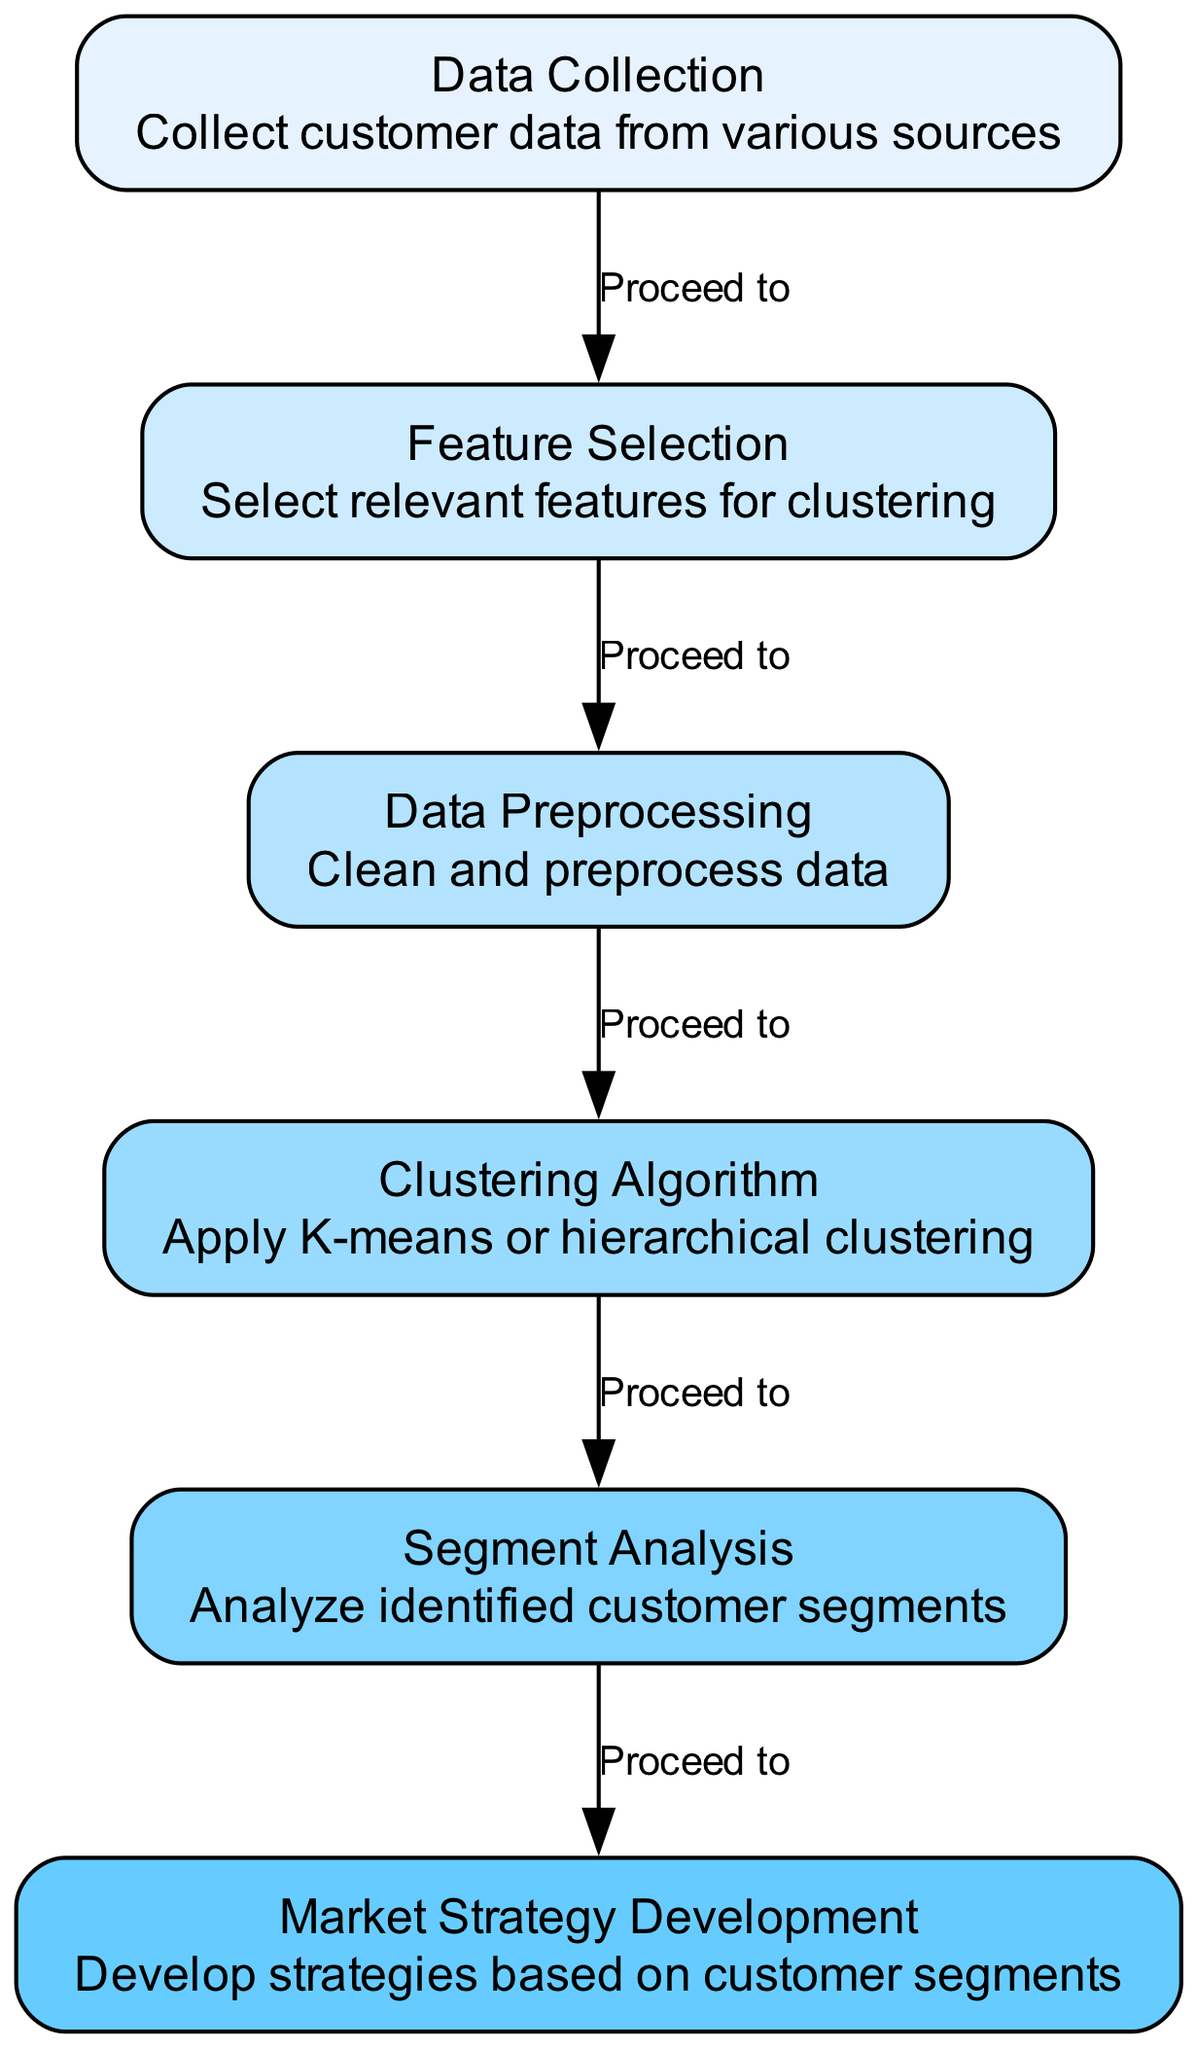What is the first step in the process? The diagram shows "Data Collection" as the first node, indicating it is the initial step in the customer behavior segmentation process.
Answer: Data Collection How many nodes are depicted in the diagram? By counting the distinct nodes in the diagram, we identify a total of six nodes that represent different stages of the process.
Answer: Six Which node follows "Clustering Algorithm"? The directed edge leads from the "Clustering Algorithm" node to the "Segment Analysis" node, indicating that segment analysis is the next step in the flow.
Answer: Segment Analysis What is the output of the "Segment Analysis" step? The diagram does not specify a direct output for "Segment Analysis," but it implies that it leads to the next stage of "Market Strategy Development."
Answer: Market Strategy Development Which two nodes are linked directly? The diagram indicates a direct link between "Feature Selection" and "Data Preprocessing," as there is an edge connecting these two nodes, showing the sequential flow.
Answer: Feature Selection and Data Preprocessing What is the purpose of the "Feature Selection" node? The description associated with the "Feature Selection" node mentions that it is focused on selecting relevant features for the clustering process, highlighting its role in the analysis workflow.
Answer: Select relevant features What is the last step in the process depicted in the diagram? The sequence ends with the "Market Strategy Development" node, which signifies the final step after analyzing customer segments.
Answer: Market Strategy Development Which node is described as performing data cleaning? The "Data Preprocessing" node is specifically described with the task of cleaning and preprocessing data, making it responsible for this crucial step.
Answer: Data Preprocessing What type of clustering methods are mentioned in the diagram? The "Clustering Algorithm" node mentions two clustering methods: K-means and hierarchical clustering, indicating the techniques employed for segmenting the customer data.
Answer: K-means or hierarchical 